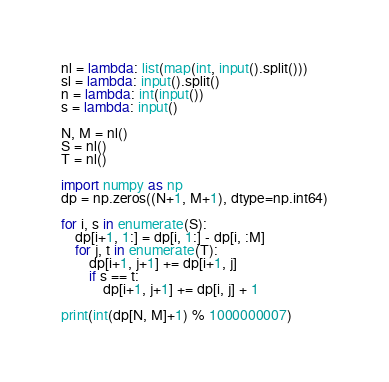<code> <loc_0><loc_0><loc_500><loc_500><_Python_>nl = lambda: list(map(int, input().split()))
sl = lambda: input().split()
n = lambda: int(input())
s = lambda: input()

N, M = nl()
S = nl()
T = nl()

import numpy as np
dp = np.zeros((N+1, M+1), dtype=np.int64)

for i, s in enumerate(S):
    dp[i+1, 1:] = dp[i, 1:] - dp[i, :M]
    for j, t in enumerate(T):
        dp[i+1, j+1] += dp[i+1, j]
        if s == t:
            dp[i+1, j+1] += dp[i, j] + 1

print(int(dp[N, M]+1) % 1000000007)
</code> 